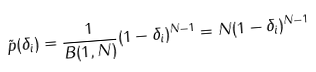<formula> <loc_0><loc_0><loc_500><loc_500>\tilde { p } ( \delta _ { i } ) = \frac { 1 } { B ( 1 , N ) } ( 1 - \delta _ { i } ) ^ { N - 1 } = N ( 1 - \delta _ { i } ) ^ { N - 1 }</formula> 